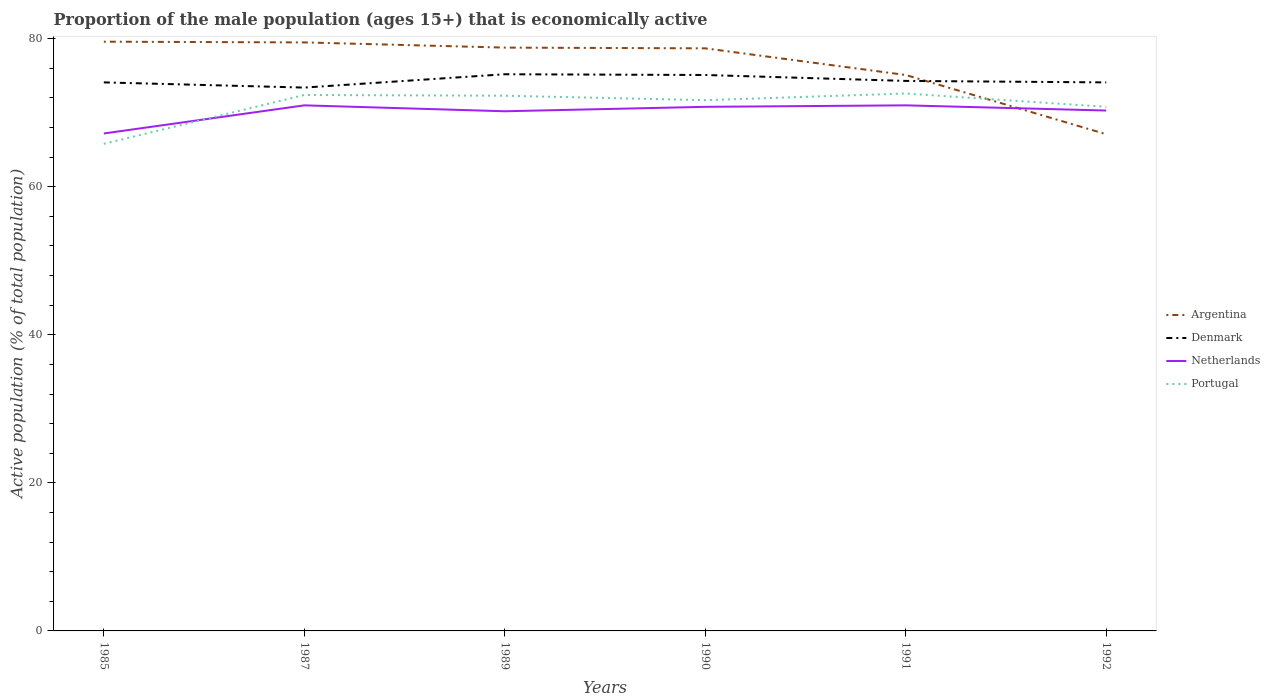How many different coloured lines are there?
Your answer should be compact. 4. Is the number of lines equal to the number of legend labels?
Provide a succinct answer. Yes. Across all years, what is the maximum proportion of the male population that is economically active in Portugal?
Give a very brief answer. 65.8. What is the difference between the highest and the second highest proportion of the male population that is economically active in Netherlands?
Provide a succinct answer. 3.8. What is the difference between the highest and the lowest proportion of the male population that is economically active in Denmark?
Your answer should be compact. 2. How many lines are there?
Give a very brief answer. 4. How many years are there in the graph?
Keep it short and to the point. 6. What is the difference between two consecutive major ticks on the Y-axis?
Your response must be concise. 20. Does the graph contain grids?
Your answer should be very brief. No. Where does the legend appear in the graph?
Ensure brevity in your answer.  Center right. How many legend labels are there?
Give a very brief answer. 4. How are the legend labels stacked?
Make the answer very short. Vertical. What is the title of the graph?
Provide a short and direct response. Proportion of the male population (ages 15+) that is economically active. Does "Thailand" appear as one of the legend labels in the graph?
Offer a terse response. No. What is the label or title of the X-axis?
Your answer should be very brief. Years. What is the label or title of the Y-axis?
Provide a short and direct response. Active population (% of total population). What is the Active population (% of total population) in Argentina in 1985?
Your answer should be compact. 79.6. What is the Active population (% of total population) of Denmark in 1985?
Keep it short and to the point. 74.1. What is the Active population (% of total population) in Netherlands in 1985?
Provide a short and direct response. 67.2. What is the Active population (% of total population) of Portugal in 1985?
Provide a short and direct response. 65.8. What is the Active population (% of total population) of Argentina in 1987?
Provide a succinct answer. 79.5. What is the Active population (% of total population) in Denmark in 1987?
Provide a short and direct response. 73.4. What is the Active population (% of total population) in Portugal in 1987?
Give a very brief answer. 72.4. What is the Active population (% of total population) of Argentina in 1989?
Your response must be concise. 78.8. What is the Active population (% of total population) in Denmark in 1989?
Ensure brevity in your answer.  75.2. What is the Active population (% of total population) in Netherlands in 1989?
Provide a succinct answer. 70.2. What is the Active population (% of total population) of Portugal in 1989?
Make the answer very short. 72.3. What is the Active population (% of total population) of Argentina in 1990?
Provide a succinct answer. 78.7. What is the Active population (% of total population) of Denmark in 1990?
Make the answer very short. 75.1. What is the Active population (% of total population) in Netherlands in 1990?
Ensure brevity in your answer.  70.8. What is the Active population (% of total population) in Portugal in 1990?
Make the answer very short. 71.7. What is the Active population (% of total population) of Argentina in 1991?
Your answer should be compact. 75.1. What is the Active population (% of total population) of Denmark in 1991?
Keep it short and to the point. 74.3. What is the Active population (% of total population) of Portugal in 1991?
Ensure brevity in your answer.  72.6. What is the Active population (% of total population) of Argentina in 1992?
Provide a short and direct response. 67.1. What is the Active population (% of total population) of Denmark in 1992?
Offer a very short reply. 74.1. What is the Active population (% of total population) of Netherlands in 1992?
Provide a succinct answer. 70.3. What is the Active population (% of total population) in Portugal in 1992?
Make the answer very short. 70.8. Across all years, what is the maximum Active population (% of total population) of Argentina?
Keep it short and to the point. 79.6. Across all years, what is the maximum Active population (% of total population) in Denmark?
Provide a short and direct response. 75.2. Across all years, what is the maximum Active population (% of total population) of Portugal?
Provide a succinct answer. 72.6. Across all years, what is the minimum Active population (% of total population) in Argentina?
Your response must be concise. 67.1. Across all years, what is the minimum Active population (% of total population) of Denmark?
Your answer should be very brief. 73.4. Across all years, what is the minimum Active population (% of total population) of Netherlands?
Provide a short and direct response. 67.2. Across all years, what is the minimum Active population (% of total population) in Portugal?
Give a very brief answer. 65.8. What is the total Active population (% of total population) of Argentina in the graph?
Make the answer very short. 458.8. What is the total Active population (% of total population) of Denmark in the graph?
Give a very brief answer. 446.2. What is the total Active population (% of total population) in Netherlands in the graph?
Your answer should be very brief. 420.5. What is the total Active population (% of total population) of Portugal in the graph?
Give a very brief answer. 425.6. What is the difference between the Active population (% of total population) of Netherlands in 1985 and that in 1987?
Provide a short and direct response. -3.8. What is the difference between the Active population (% of total population) of Argentina in 1985 and that in 1989?
Give a very brief answer. 0.8. What is the difference between the Active population (% of total population) in Portugal in 1985 and that in 1990?
Offer a terse response. -5.9. What is the difference between the Active population (% of total population) of Argentina in 1985 and that in 1991?
Your answer should be compact. 4.5. What is the difference between the Active population (% of total population) in Netherlands in 1985 and that in 1991?
Your answer should be very brief. -3.8. What is the difference between the Active population (% of total population) of Portugal in 1985 and that in 1991?
Offer a very short reply. -6.8. What is the difference between the Active population (% of total population) in Netherlands in 1985 and that in 1992?
Give a very brief answer. -3.1. What is the difference between the Active population (% of total population) in Denmark in 1987 and that in 1990?
Provide a succinct answer. -1.7. What is the difference between the Active population (% of total population) in Netherlands in 1987 and that in 1990?
Ensure brevity in your answer.  0.2. What is the difference between the Active population (% of total population) in Portugal in 1987 and that in 1990?
Keep it short and to the point. 0.7. What is the difference between the Active population (% of total population) of Argentina in 1987 and that in 1991?
Offer a very short reply. 4.4. What is the difference between the Active population (% of total population) of Portugal in 1987 and that in 1991?
Offer a very short reply. -0.2. What is the difference between the Active population (% of total population) of Argentina in 1987 and that in 1992?
Give a very brief answer. 12.4. What is the difference between the Active population (% of total population) of Denmark in 1987 and that in 1992?
Your response must be concise. -0.7. What is the difference between the Active population (% of total population) of Portugal in 1987 and that in 1992?
Give a very brief answer. 1.6. What is the difference between the Active population (% of total population) in Argentina in 1989 and that in 1990?
Your answer should be compact. 0.1. What is the difference between the Active population (% of total population) of Denmark in 1989 and that in 1990?
Provide a short and direct response. 0.1. What is the difference between the Active population (% of total population) in Argentina in 1989 and that in 1991?
Your response must be concise. 3.7. What is the difference between the Active population (% of total population) of Denmark in 1989 and that in 1991?
Provide a short and direct response. 0.9. What is the difference between the Active population (% of total population) of Portugal in 1989 and that in 1991?
Keep it short and to the point. -0.3. What is the difference between the Active population (% of total population) of Argentina in 1989 and that in 1992?
Offer a very short reply. 11.7. What is the difference between the Active population (% of total population) in Denmark in 1989 and that in 1992?
Ensure brevity in your answer.  1.1. What is the difference between the Active population (% of total population) of Argentina in 1990 and that in 1991?
Make the answer very short. 3.6. What is the difference between the Active population (% of total population) in Denmark in 1990 and that in 1991?
Offer a terse response. 0.8. What is the difference between the Active population (% of total population) of Netherlands in 1990 and that in 1991?
Your answer should be compact. -0.2. What is the difference between the Active population (% of total population) in Portugal in 1990 and that in 1991?
Your answer should be very brief. -0.9. What is the difference between the Active population (% of total population) in Denmark in 1990 and that in 1992?
Your answer should be compact. 1. What is the difference between the Active population (% of total population) of Netherlands in 1990 and that in 1992?
Offer a very short reply. 0.5. What is the difference between the Active population (% of total population) of Denmark in 1991 and that in 1992?
Provide a short and direct response. 0.2. What is the difference between the Active population (% of total population) of Netherlands in 1991 and that in 1992?
Your response must be concise. 0.7. What is the difference between the Active population (% of total population) of Portugal in 1991 and that in 1992?
Provide a succinct answer. 1.8. What is the difference between the Active population (% of total population) in Argentina in 1985 and the Active population (% of total population) in Denmark in 1987?
Provide a short and direct response. 6.2. What is the difference between the Active population (% of total population) in Argentina in 1985 and the Active population (% of total population) in Netherlands in 1987?
Offer a very short reply. 8.6. What is the difference between the Active population (% of total population) in Argentina in 1985 and the Active population (% of total population) in Portugal in 1987?
Provide a short and direct response. 7.2. What is the difference between the Active population (% of total population) of Netherlands in 1985 and the Active population (% of total population) of Portugal in 1987?
Your answer should be compact. -5.2. What is the difference between the Active population (% of total population) of Argentina in 1985 and the Active population (% of total population) of Portugal in 1989?
Provide a short and direct response. 7.3. What is the difference between the Active population (% of total population) of Denmark in 1985 and the Active population (% of total population) of Netherlands in 1989?
Give a very brief answer. 3.9. What is the difference between the Active population (% of total population) in Argentina in 1985 and the Active population (% of total population) in Denmark in 1990?
Your answer should be very brief. 4.5. What is the difference between the Active population (% of total population) in Argentina in 1985 and the Active population (% of total population) in Portugal in 1990?
Make the answer very short. 7.9. What is the difference between the Active population (% of total population) in Argentina in 1985 and the Active population (% of total population) in Netherlands in 1991?
Ensure brevity in your answer.  8.6. What is the difference between the Active population (% of total population) of Denmark in 1985 and the Active population (% of total population) of Netherlands in 1991?
Ensure brevity in your answer.  3.1. What is the difference between the Active population (% of total population) in Netherlands in 1985 and the Active population (% of total population) in Portugal in 1991?
Your response must be concise. -5.4. What is the difference between the Active population (% of total population) of Argentina in 1985 and the Active population (% of total population) of Netherlands in 1992?
Offer a terse response. 9.3. What is the difference between the Active population (% of total population) of Denmark in 1985 and the Active population (% of total population) of Netherlands in 1992?
Keep it short and to the point. 3.8. What is the difference between the Active population (% of total population) of Argentina in 1987 and the Active population (% of total population) of Netherlands in 1989?
Offer a terse response. 9.3. What is the difference between the Active population (% of total population) of Argentina in 1987 and the Active population (% of total population) of Portugal in 1989?
Ensure brevity in your answer.  7.2. What is the difference between the Active population (% of total population) of Denmark in 1987 and the Active population (% of total population) of Netherlands in 1989?
Provide a short and direct response. 3.2. What is the difference between the Active population (% of total population) of Denmark in 1987 and the Active population (% of total population) of Portugal in 1989?
Keep it short and to the point. 1.1. What is the difference between the Active population (% of total population) of Netherlands in 1987 and the Active population (% of total population) of Portugal in 1989?
Your response must be concise. -1.3. What is the difference between the Active population (% of total population) in Argentina in 1987 and the Active population (% of total population) in Denmark in 1990?
Give a very brief answer. 4.4. What is the difference between the Active population (% of total population) of Denmark in 1987 and the Active population (% of total population) of Netherlands in 1990?
Offer a terse response. 2.6. What is the difference between the Active population (% of total population) in Netherlands in 1987 and the Active population (% of total population) in Portugal in 1990?
Offer a terse response. -0.7. What is the difference between the Active population (% of total population) in Argentina in 1987 and the Active population (% of total population) in Denmark in 1991?
Offer a terse response. 5.2. What is the difference between the Active population (% of total population) in Argentina in 1987 and the Active population (% of total population) in Portugal in 1991?
Offer a very short reply. 6.9. What is the difference between the Active population (% of total population) in Netherlands in 1987 and the Active population (% of total population) in Portugal in 1991?
Your answer should be very brief. -1.6. What is the difference between the Active population (% of total population) of Argentina in 1987 and the Active population (% of total population) of Netherlands in 1992?
Give a very brief answer. 9.2. What is the difference between the Active population (% of total population) in Argentina in 1989 and the Active population (% of total population) in Denmark in 1990?
Ensure brevity in your answer.  3.7. What is the difference between the Active population (% of total population) in Argentina in 1989 and the Active population (% of total population) in Netherlands in 1990?
Offer a terse response. 8. What is the difference between the Active population (% of total population) in Argentina in 1989 and the Active population (% of total population) in Denmark in 1991?
Offer a terse response. 4.5. What is the difference between the Active population (% of total population) of Argentina in 1989 and the Active population (% of total population) of Netherlands in 1991?
Offer a very short reply. 7.8. What is the difference between the Active population (% of total population) of Denmark in 1989 and the Active population (% of total population) of Portugal in 1991?
Your response must be concise. 2.6. What is the difference between the Active population (% of total population) in Netherlands in 1989 and the Active population (% of total population) in Portugal in 1991?
Give a very brief answer. -2.4. What is the difference between the Active population (% of total population) of Argentina in 1989 and the Active population (% of total population) of Denmark in 1992?
Ensure brevity in your answer.  4.7. What is the difference between the Active population (% of total population) of Argentina in 1989 and the Active population (% of total population) of Netherlands in 1992?
Keep it short and to the point. 8.5. What is the difference between the Active population (% of total population) of Denmark in 1989 and the Active population (% of total population) of Netherlands in 1992?
Offer a very short reply. 4.9. What is the difference between the Active population (% of total population) of Denmark in 1989 and the Active population (% of total population) of Portugal in 1992?
Ensure brevity in your answer.  4.4. What is the difference between the Active population (% of total population) in Argentina in 1990 and the Active population (% of total population) in Portugal in 1991?
Your response must be concise. 6.1. What is the difference between the Active population (% of total population) of Denmark in 1990 and the Active population (% of total population) of Portugal in 1991?
Your response must be concise. 2.5. What is the difference between the Active population (% of total population) in Netherlands in 1990 and the Active population (% of total population) in Portugal in 1991?
Make the answer very short. -1.8. What is the difference between the Active population (% of total population) of Argentina in 1990 and the Active population (% of total population) of Denmark in 1992?
Your answer should be very brief. 4.6. What is the difference between the Active population (% of total population) in Argentina in 1990 and the Active population (% of total population) in Netherlands in 1992?
Ensure brevity in your answer.  8.4. What is the difference between the Active population (% of total population) of Argentina in 1990 and the Active population (% of total population) of Portugal in 1992?
Your answer should be compact. 7.9. What is the difference between the Active population (% of total population) in Denmark in 1990 and the Active population (% of total population) in Netherlands in 1992?
Offer a very short reply. 4.8. What is the difference between the Active population (% of total population) in Denmark in 1990 and the Active population (% of total population) in Portugal in 1992?
Make the answer very short. 4.3. What is the difference between the Active population (% of total population) in Netherlands in 1990 and the Active population (% of total population) in Portugal in 1992?
Provide a short and direct response. 0. What is the difference between the Active population (% of total population) in Argentina in 1991 and the Active population (% of total population) in Denmark in 1992?
Give a very brief answer. 1. What is the difference between the Active population (% of total population) in Argentina in 1991 and the Active population (% of total population) in Portugal in 1992?
Your answer should be compact. 4.3. What is the difference between the Active population (% of total population) in Denmark in 1991 and the Active population (% of total population) in Netherlands in 1992?
Provide a short and direct response. 4. What is the average Active population (% of total population) in Argentina per year?
Give a very brief answer. 76.47. What is the average Active population (% of total population) in Denmark per year?
Your answer should be very brief. 74.37. What is the average Active population (% of total population) in Netherlands per year?
Offer a very short reply. 70.08. What is the average Active population (% of total population) of Portugal per year?
Offer a terse response. 70.93. In the year 1985, what is the difference between the Active population (% of total population) in Argentina and Active population (% of total population) in Portugal?
Offer a very short reply. 13.8. In the year 1985, what is the difference between the Active population (% of total population) of Denmark and Active population (% of total population) of Portugal?
Offer a very short reply. 8.3. In the year 1985, what is the difference between the Active population (% of total population) of Netherlands and Active population (% of total population) of Portugal?
Give a very brief answer. 1.4. In the year 1987, what is the difference between the Active population (% of total population) in Argentina and Active population (% of total population) in Denmark?
Your response must be concise. 6.1. In the year 1987, what is the difference between the Active population (% of total population) in Denmark and Active population (% of total population) in Netherlands?
Offer a very short reply. 2.4. In the year 1987, what is the difference between the Active population (% of total population) of Denmark and Active population (% of total population) of Portugal?
Your response must be concise. 1. In the year 1989, what is the difference between the Active population (% of total population) of Argentina and Active population (% of total population) of Denmark?
Provide a short and direct response. 3.6. In the year 1989, what is the difference between the Active population (% of total population) in Argentina and Active population (% of total population) in Portugal?
Provide a short and direct response. 6.5. In the year 1989, what is the difference between the Active population (% of total population) of Denmark and Active population (% of total population) of Netherlands?
Provide a short and direct response. 5. In the year 1990, what is the difference between the Active population (% of total population) in Argentina and Active population (% of total population) in Denmark?
Your response must be concise. 3.6. In the year 1990, what is the difference between the Active population (% of total population) in Argentina and Active population (% of total population) in Netherlands?
Ensure brevity in your answer.  7.9. In the year 1990, what is the difference between the Active population (% of total population) of Argentina and Active population (% of total population) of Portugal?
Your response must be concise. 7. In the year 1990, what is the difference between the Active population (% of total population) in Denmark and Active population (% of total population) in Portugal?
Offer a terse response. 3.4. In the year 1990, what is the difference between the Active population (% of total population) of Netherlands and Active population (% of total population) of Portugal?
Offer a terse response. -0.9. In the year 1991, what is the difference between the Active population (% of total population) in Argentina and Active population (% of total population) in Denmark?
Provide a short and direct response. 0.8. In the year 1991, what is the difference between the Active population (% of total population) in Argentina and Active population (% of total population) in Portugal?
Your response must be concise. 2.5. In the year 1991, what is the difference between the Active population (% of total population) of Netherlands and Active population (% of total population) of Portugal?
Your response must be concise. -1.6. In the year 1992, what is the difference between the Active population (% of total population) of Denmark and Active population (% of total population) of Netherlands?
Give a very brief answer. 3.8. In the year 1992, what is the difference between the Active population (% of total population) in Netherlands and Active population (% of total population) in Portugal?
Provide a succinct answer. -0.5. What is the ratio of the Active population (% of total population) of Argentina in 1985 to that in 1987?
Ensure brevity in your answer.  1. What is the ratio of the Active population (% of total population) of Denmark in 1985 to that in 1987?
Keep it short and to the point. 1.01. What is the ratio of the Active population (% of total population) of Netherlands in 1985 to that in 1987?
Ensure brevity in your answer.  0.95. What is the ratio of the Active population (% of total population) of Portugal in 1985 to that in 1987?
Your answer should be compact. 0.91. What is the ratio of the Active population (% of total population) of Argentina in 1985 to that in 1989?
Your response must be concise. 1.01. What is the ratio of the Active population (% of total population) in Denmark in 1985 to that in 1989?
Keep it short and to the point. 0.99. What is the ratio of the Active population (% of total population) of Netherlands in 1985 to that in 1989?
Offer a very short reply. 0.96. What is the ratio of the Active population (% of total population) of Portugal in 1985 to that in 1989?
Give a very brief answer. 0.91. What is the ratio of the Active population (% of total population) in Argentina in 1985 to that in 1990?
Offer a terse response. 1.01. What is the ratio of the Active population (% of total population) of Denmark in 1985 to that in 1990?
Keep it short and to the point. 0.99. What is the ratio of the Active population (% of total population) in Netherlands in 1985 to that in 1990?
Your response must be concise. 0.95. What is the ratio of the Active population (% of total population) of Portugal in 1985 to that in 1990?
Offer a very short reply. 0.92. What is the ratio of the Active population (% of total population) of Argentina in 1985 to that in 1991?
Give a very brief answer. 1.06. What is the ratio of the Active population (% of total population) in Denmark in 1985 to that in 1991?
Provide a succinct answer. 1. What is the ratio of the Active population (% of total population) in Netherlands in 1985 to that in 1991?
Your answer should be compact. 0.95. What is the ratio of the Active population (% of total population) in Portugal in 1985 to that in 1991?
Offer a terse response. 0.91. What is the ratio of the Active population (% of total population) of Argentina in 1985 to that in 1992?
Provide a succinct answer. 1.19. What is the ratio of the Active population (% of total population) in Denmark in 1985 to that in 1992?
Keep it short and to the point. 1. What is the ratio of the Active population (% of total population) in Netherlands in 1985 to that in 1992?
Provide a short and direct response. 0.96. What is the ratio of the Active population (% of total population) of Portugal in 1985 to that in 1992?
Your answer should be compact. 0.93. What is the ratio of the Active population (% of total population) of Argentina in 1987 to that in 1989?
Offer a very short reply. 1.01. What is the ratio of the Active population (% of total population) of Denmark in 1987 to that in 1989?
Give a very brief answer. 0.98. What is the ratio of the Active population (% of total population) of Netherlands in 1987 to that in 1989?
Your answer should be compact. 1.01. What is the ratio of the Active population (% of total population) of Portugal in 1987 to that in 1989?
Give a very brief answer. 1. What is the ratio of the Active population (% of total population) in Argentina in 1987 to that in 1990?
Your answer should be compact. 1.01. What is the ratio of the Active population (% of total population) of Denmark in 1987 to that in 1990?
Your response must be concise. 0.98. What is the ratio of the Active population (% of total population) of Portugal in 1987 to that in 1990?
Your answer should be very brief. 1.01. What is the ratio of the Active population (% of total population) in Argentina in 1987 to that in 1991?
Your answer should be very brief. 1.06. What is the ratio of the Active population (% of total population) in Denmark in 1987 to that in 1991?
Keep it short and to the point. 0.99. What is the ratio of the Active population (% of total population) in Argentina in 1987 to that in 1992?
Make the answer very short. 1.18. What is the ratio of the Active population (% of total population) of Denmark in 1987 to that in 1992?
Ensure brevity in your answer.  0.99. What is the ratio of the Active population (% of total population) of Netherlands in 1987 to that in 1992?
Keep it short and to the point. 1.01. What is the ratio of the Active population (% of total population) in Portugal in 1987 to that in 1992?
Your answer should be compact. 1.02. What is the ratio of the Active population (% of total population) of Argentina in 1989 to that in 1990?
Your response must be concise. 1. What is the ratio of the Active population (% of total population) of Portugal in 1989 to that in 1990?
Make the answer very short. 1.01. What is the ratio of the Active population (% of total population) of Argentina in 1989 to that in 1991?
Give a very brief answer. 1.05. What is the ratio of the Active population (% of total population) in Denmark in 1989 to that in 1991?
Ensure brevity in your answer.  1.01. What is the ratio of the Active population (% of total population) of Netherlands in 1989 to that in 1991?
Ensure brevity in your answer.  0.99. What is the ratio of the Active population (% of total population) of Argentina in 1989 to that in 1992?
Provide a succinct answer. 1.17. What is the ratio of the Active population (% of total population) in Denmark in 1989 to that in 1992?
Offer a very short reply. 1.01. What is the ratio of the Active population (% of total population) of Portugal in 1989 to that in 1992?
Ensure brevity in your answer.  1.02. What is the ratio of the Active population (% of total population) of Argentina in 1990 to that in 1991?
Make the answer very short. 1.05. What is the ratio of the Active population (% of total population) in Denmark in 1990 to that in 1991?
Make the answer very short. 1.01. What is the ratio of the Active population (% of total population) of Portugal in 1990 to that in 1991?
Provide a succinct answer. 0.99. What is the ratio of the Active population (% of total population) in Argentina in 1990 to that in 1992?
Keep it short and to the point. 1.17. What is the ratio of the Active population (% of total population) in Denmark in 1990 to that in 1992?
Give a very brief answer. 1.01. What is the ratio of the Active population (% of total population) of Netherlands in 1990 to that in 1992?
Offer a very short reply. 1.01. What is the ratio of the Active population (% of total population) in Portugal in 1990 to that in 1992?
Give a very brief answer. 1.01. What is the ratio of the Active population (% of total population) of Argentina in 1991 to that in 1992?
Ensure brevity in your answer.  1.12. What is the ratio of the Active population (% of total population) of Denmark in 1991 to that in 1992?
Your response must be concise. 1. What is the ratio of the Active population (% of total population) in Netherlands in 1991 to that in 1992?
Give a very brief answer. 1.01. What is the ratio of the Active population (% of total population) of Portugal in 1991 to that in 1992?
Give a very brief answer. 1.03. What is the difference between the highest and the second highest Active population (% of total population) in Argentina?
Your answer should be compact. 0.1. What is the difference between the highest and the second highest Active population (% of total population) of Denmark?
Offer a terse response. 0.1. What is the difference between the highest and the second highest Active population (% of total population) of Netherlands?
Give a very brief answer. 0. What is the difference between the highest and the second highest Active population (% of total population) of Portugal?
Provide a short and direct response. 0.2. What is the difference between the highest and the lowest Active population (% of total population) of Denmark?
Your response must be concise. 1.8. 